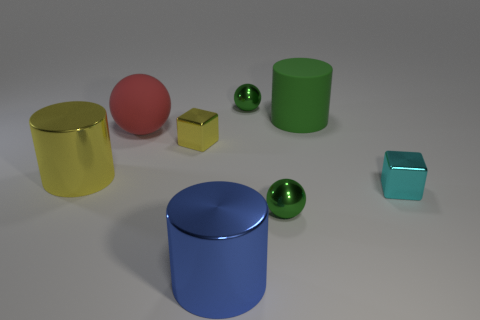Subtract all metallic cylinders. How many cylinders are left? 1 Subtract all cyan blocks. How many blocks are left? 1 Add 1 metal things. How many objects exist? 9 Subtract 1 balls. How many balls are left? 2 Subtract all cylinders. How many objects are left? 5 Subtract all small cubes. Subtract all tiny shiny blocks. How many objects are left? 4 Add 6 small yellow metal blocks. How many small yellow metal blocks are left? 7 Add 3 blue matte spheres. How many blue matte spheres exist? 3 Subtract 0 gray blocks. How many objects are left? 8 Subtract all brown spheres. Subtract all cyan cubes. How many spheres are left? 3 